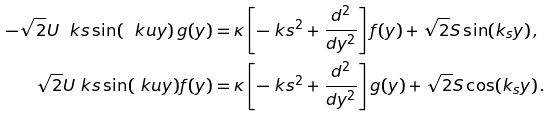<formula> <loc_0><loc_0><loc_500><loc_500>- \sqrt { 2 } U \ k s \sin ( \ k u y ) \, g ( y ) & = \kappa \left [ - \ k s ^ { 2 } + \frac { d ^ { 2 } } { d y ^ { 2 } } \right ] f ( y ) + \sqrt { 2 } S \sin ( k _ { s } y ) \, , \\ \sqrt { 2 } U \ k s \sin ( \ k u y ) f ( y ) & = \kappa \left [ - \ k s ^ { 2 } + \frac { d ^ { 2 } } { d y ^ { 2 } } \right ] g ( y ) + \sqrt { 2 } S \cos ( k _ { s } y ) \, .</formula> 